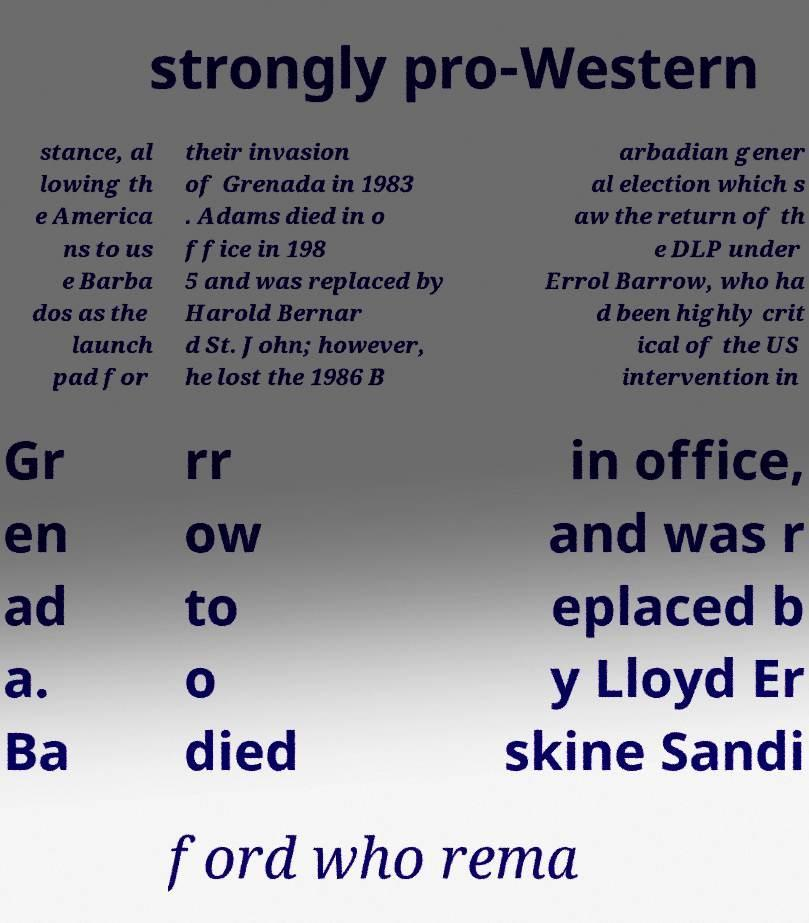Can you read and provide the text displayed in the image?This photo seems to have some interesting text. Can you extract and type it out for me? strongly pro-Western stance, al lowing th e America ns to us e Barba dos as the launch pad for their invasion of Grenada in 1983 . Adams died in o ffice in 198 5 and was replaced by Harold Bernar d St. John; however, he lost the 1986 B arbadian gener al election which s aw the return of th e DLP under Errol Barrow, who ha d been highly crit ical of the US intervention in Gr en ad a. Ba rr ow to o died in office, and was r eplaced b y Lloyd Er skine Sandi ford who rema 